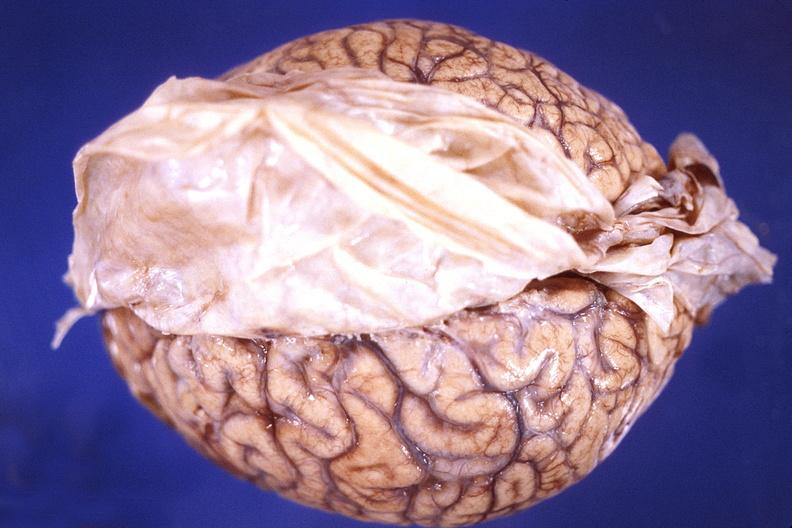what is present?
Answer the question using a single word or phrase. Nervous 